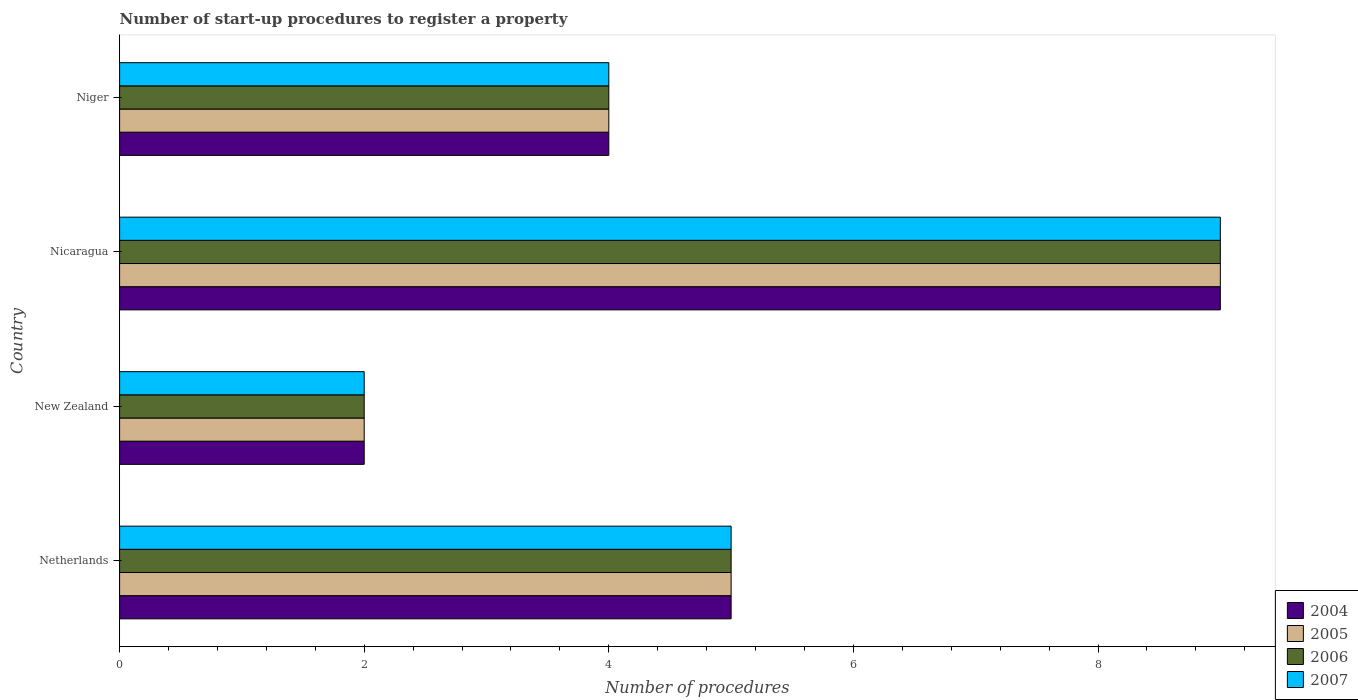How many different coloured bars are there?
Your answer should be compact. 4. Are the number of bars per tick equal to the number of legend labels?
Offer a very short reply. Yes. Are the number of bars on each tick of the Y-axis equal?
Your answer should be very brief. Yes. How many bars are there on the 1st tick from the top?
Your response must be concise. 4. What is the label of the 1st group of bars from the top?
Your response must be concise. Niger. In how many cases, is the number of bars for a given country not equal to the number of legend labels?
Provide a short and direct response. 0. In which country was the number of procedures required to register a property in 2005 maximum?
Your response must be concise. Nicaragua. In which country was the number of procedures required to register a property in 2005 minimum?
Make the answer very short. New Zealand. What is the total number of procedures required to register a property in 2005 in the graph?
Provide a short and direct response. 20. What is the difference between the number of procedures required to register a property in 2007 in Netherlands and that in New Zealand?
Offer a very short reply. 3. What is the average number of procedures required to register a property in 2007 per country?
Ensure brevity in your answer.  5. What is the ratio of the number of procedures required to register a property in 2007 in Netherlands to that in New Zealand?
Your response must be concise. 2.5. Is the number of procedures required to register a property in 2006 in Netherlands less than that in New Zealand?
Offer a very short reply. No. Is the difference between the number of procedures required to register a property in 2004 in Netherlands and New Zealand greater than the difference between the number of procedures required to register a property in 2007 in Netherlands and New Zealand?
Your answer should be compact. No. What is the difference between the highest and the lowest number of procedures required to register a property in 2006?
Provide a short and direct response. 7. Is it the case that in every country, the sum of the number of procedures required to register a property in 2005 and number of procedures required to register a property in 2007 is greater than the sum of number of procedures required to register a property in 2006 and number of procedures required to register a property in 2004?
Offer a very short reply. No. What does the 2nd bar from the bottom in New Zealand represents?
Provide a short and direct response. 2005. How many bars are there?
Your answer should be very brief. 16. How many countries are there in the graph?
Provide a succinct answer. 4. Does the graph contain grids?
Offer a very short reply. No. Where does the legend appear in the graph?
Offer a terse response. Bottom right. How are the legend labels stacked?
Give a very brief answer. Vertical. What is the title of the graph?
Make the answer very short. Number of start-up procedures to register a property. What is the label or title of the X-axis?
Make the answer very short. Number of procedures. What is the Number of procedures of 2004 in Netherlands?
Your response must be concise. 5. What is the Number of procedures of 2005 in Netherlands?
Provide a short and direct response. 5. What is the Number of procedures of 2006 in Netherlands?
Your answer should be very brief. 5. What is the Number of procedures in 2007 in Netherlands?
Keep it short and to the point. 5. What is the Number of procedures of 2005 in New Zealand?
Your answer should be very brief. 2. What is the Number of procedures of 2006 in New Zealand?
Your response must be concise. 2. What is the Number of procedures of 2006 in Nicaragua?
Provide a short and direct response. 9. What is the Number of procedures of 2007 in Nicaragua?
Your answer should be compact. 9. What is the Number of procedures in 2004 in Niger?
Offer a very short reply. 4. What is the Number of procedures in 2005 in Niger?
Give a very brief answer. 4. What is the Number of procedures in 2006 in Niger?
Your answer should be very brief. 4. What is the Number of procedures in 2007 in Niger?
Offer a very short reply. 4. Across all countries, what is the maximum Number of procedures of 2004?
Give a very brief answer. 9. Across all countries, what is the maximum Number of procedures of 2005?
Offer a terse response. 9. Across all countries, what is the minimum Number of procedures in 2007?
Your response must be concise. 2. What is the total Number of procedures in 2004 in the graph?
Keep it short and to the point. 20. What is the total Number of procedures of 2005 in the graph?
Make the answer very short. 20. What is the total Number of procedures in 2007 in the graph?
Provide a succinct answer. 20. What is the difference between the Number of procedures of 2004 in Netherlands and that in New Zealand?
Your answer should be compact. 3. What is the difference between the Number of procedures of 2005 in Netherlands and that in New Zealand?
Your answer should be very brief. 3. What is the difference between the Number of procedures of 2006 in Netherlands and that in New Zealand?
Your response must be concise. 3. What is the difference between the Number of procedures of 2007 in Netherlands and that in New Zealand?
Your response must be concise. 3. What is the difference between the Number of procedures in 2004 in Netherlands and that in Nicaragua?
Ensure brevity in your answer.  -4. What is the difference between the Number of procedures in 2005 in Netherlands and that in Nicaragua?
Keep it short and to the point. -4. What is the difference between the Number of procedures of 2007 in Netherlands and that in Nicaragua?
Ensure brevity in your answer.  -4. What is the difference between the Number of procedures of 2004 in Netherlands and that in Niger?
Your answer should be very brief. 1. What is the difference between the Number of procedures in 2005 in Netherlands and that in Niger?
Offer a terse response. 1. What is the difference between the Number of procedures in 2006 in Netherlands and that in Niger?
Your response must be concise. 1. What is the difference between the Number of procedures in 2007 in Netherlands and that in Niger?
Keep it short and to the point. 1. What is the difference between the Number of procedures in 2004 in New Zealand and that in Nicaragua?
Your answer should be compact. -7. What is the difference between the Number of procedures of 2007 in New Zealand and that in Nicaragua?
Provide a short and direct response. -7. What is the difference between the Number of procedures in 2004 in New Zealand and that in Niger?
Give a very brief answer. -2. What is the difference between the Number of procedures in 2005 in New Zealand and that in Niger?
Your answer should be very brief. -2. What is the difference between the Number of procedures of 2004 in Nicaragua and that in Niger?
Keep it short and to the point. 5. What is the difference between the Number of procedures of 2005 in Nicaragua and that in Niger?
Keep it short and to the point. 5. What is the difference between the Number of procedures of 2004 in Netherlands and the Number of procedures of 2005 in New Zealand?
Ensure brevity in your answer.  3. What is the difference between the Number of procedures in 2005 in Netherlands and the Number of procedures in 2007 in New Zealand?
Provide a succinct answer. 3. What is the difference between the Number of procedures of 2006 in Netherlands and the Number of procedures of 2007 in New Zealand?
Make the answer very short. 3. What is the difference between the Number of procedures in 2004 in Netherlands and the Number of procedures in 2005 in Nicaragua?
Your answer should be very brief. -4. What is the difference between the Number of procedures in 2005 in Netherlands and the Number of procedures in 2006 in Nicaragua?
Keep it short and to the point. -4. What is the difference between the Number of procedures of 2005 in Netherlands and the Number of procedures of 2007 in Nicaragua?
Your response must be concise. -4. What is the difference between the Number of procedures of 2004 in Netherlands and the Number of procedures of 2005 in Niger?
Give a very brief answer. 1. What is the difference between the Number of procedures in 2005 in Netherlands and the Number of procedures in 2006 in Niger?
Make the answer very short. 1. What is the difference between the Number of procedures of 2005 in Netherlands and the Number of procedures of 2007 in Niger?
Ensure brevity in your answer.  1. What is the difference between the Number of procedures in 2004 in New Zealand and the Number of procedures in 2007 in Nicaragua?
Your answer should be very brief. -7. What is the difference between the Number of procedures in 2005 in New Zealand and the Number of procedures in 2006 in Nicaragua?
Offer a terse response. -7. What is the difference between the Number of procedures of 2004 in New Zealand and the Number of procedures of 2007 in Niger?
Give a very brief answer. -2. What is the difference between the Number of procedures in 2005 in New Zealand and the Number of procedures in 2006 in Niger?
Provide a short and direct response. -2. What is the difference between the Number of procedures of 2006 in New Zealand and the Number of procedures of 2007 in Niger?
Your response must be concise. -2. What is the difference between the Number of procedures of 2004 in Nicaragua and the Number of procedures of 2005 in Niger?
Provide a short and direct response. 5. What is the difference between the Number of procedures of 2004 in Nicaragua and the Number of procedures of 2007 in Niger?
Your response must be concise. 5. What is the average Number of procedures in 2006 per country?
Make the answer very short. 5. What is the average Number of procedures in 2007 per country?
Offer a very short reply. 5. What is the difference between the Number of procedures in 2004 and Number of procedures in 2005 in Netherlands?
Your answer should be very brief. 0. What is the difference between the Number of procedures in 2004 and Number of procedures in 2005 in New Zealand?
Your answer should be very brief. 0. What is the difference between the Number of procedures in 2006 and Number of procedures in 2007 in New Zealand?
Offer a very short reply. 0. What is the difference between the Number of procedures in 2004 and Number of procedures in 2006 in Nicaragua?
Provide a short and direct response. 0. What is the difference between the Number of procedures of 2005 and Number of procedures of 2006 in Nicaragua?
Keep it short and to the point. 0. What is the difference between the Number of procedures of 2005 and Number of procedures of 2007 in Nicaragua?
Your response must be concise. 0. What is the difference between the Number of procedures in 2006 and Number of procedures in 2007 in Nicaragua?
Make the answer very short. 0. What is the difference between the Number of procedures in 2004 and Number of procedures in 2006 in Niger?
Offer a terse response. 0. What is the difference between the Number of procedures in 2005 and Number of procedures in 2006 in Niger?
Your answer should be very brief. 0. What is the ratio of the Number of procedures of 2005 in Netherlands to that in New Zealand?
Make the answer very short. 2.5. What is the ratio of the Number of procedures of 2006 in Netherlands to that in New Zealand?
Your answer should be compact. 2.5. What is the ratio of the Number of procedures in 2004 in Netherlands to that in Nicaragua?
Give a very brief answer. 0.56. What is the ratio of the Number of procedures in 2005 in Netherlands to that in Nicaragua?
Give a very brief answer. 0.56. What is the ratio of the Number of procedures in 2006 in Netherlands to that in Nicaragua?
Make the answer very short. 0.56. What is the ratio of the Number of procedures in 2007 in Netherlands to that in Nicaragua?
Offer a terse response. 0.56. What is the ratio of the Number of procedures in 2005 in Netherlands to that in Niger?
Your answer should be very brief. 1.25. What is the ratio of the Number of procedures in 2006 in Netherlands to that in Niger?
Ensure brevity in your answer.  1.25. What is the ratio of the Number of procedures in 2007 in Netherlands to that in Niger?
Offer a very short reply. 1.25. What is the ratio of the Number of procedures of 2004 in New Zealand to that in Nicaragua?
Your response must be concise. 0.22. What is the ratio of the Number of procedures of 2005 in New Zealand to that in Nicaragua?
Your answer should be compact. 0.22. What is the ratio of the Number of procedures in 2006 in New Zealand to that in Nicaragua?
Make the answer very short. 0.22. What is the ratio of the Number of procedures of 2007 in New Zealand to that in Nicaragua?
Ensure brevity in your answer.  0.22. What is the ratio of the Number of procedures of 2004 in New Zealand to that in Niger?
Make the answer very short. 0.5. What is the ratio of the Number of procedures in 2005 in New Zealand to that in Niger?
Give a very brief answer. 0.5. What is the ratio of the Number of procedures in 2006 in New Zealand to that in Niger?
Your answer should be very brief. 0.5. What is the ratio of the Number of procedures of 2004 in Nicaragua to that in Niger?
Provide a succinct answer. 2.25. What is the ratio of the Number of procedures of 2005 in Nicaragua to that in Niger?
Make the answer very short. 2.25. What is the ratio of the Number of procedures in 2006 in Nicaragua to that in Niger?
Provide a succinct answer. 2.25. What is the ratio of the Number of procedures in 2007 in Nicaragua to that in Niger?
Ensure brevity in your answer.  2.25. What is the difference between the highest and the second highest Number of procedures in 2004?
Make the answer very short. 4. What is the difference between the highest and the second highest Number of procedures in 2006?
Provide a short and direct response. 4. What is the difference between the highest and the lowest Number of procedures in 2005?
Keep it short and to the point. 7. What is the difference between the highest and the lowest Number of procedures of 2006?
Give a very brief answer. 7. What is the difference between the highest and the lowest Number of procedures in 2007?
Your answer should be compact. 7. 